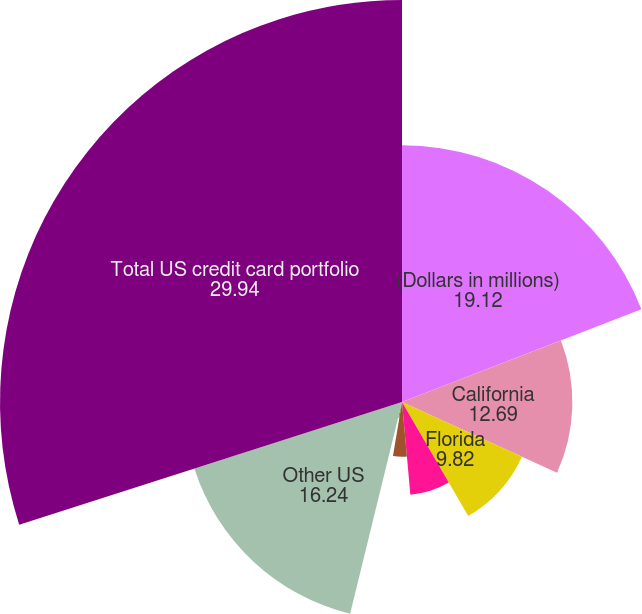Convert chart. <chart><loc_0><loc_0><loc_500><loc_500><pie_chart><fcel>(Dollars in millions)<fcel>California<fcel>Florida<fcel>Texas<fcel>New York<fcel>New Jersey<fcel>Other US<fcel>Total US credit card portfolio<nl><fcel>19.12%<fcel>12.69%<fcel>9.82%<fcel>6.94%<fcel>4.07%<fcel>1.19%<fcel>16.24%<fcel>29.94%<nl></chart> 